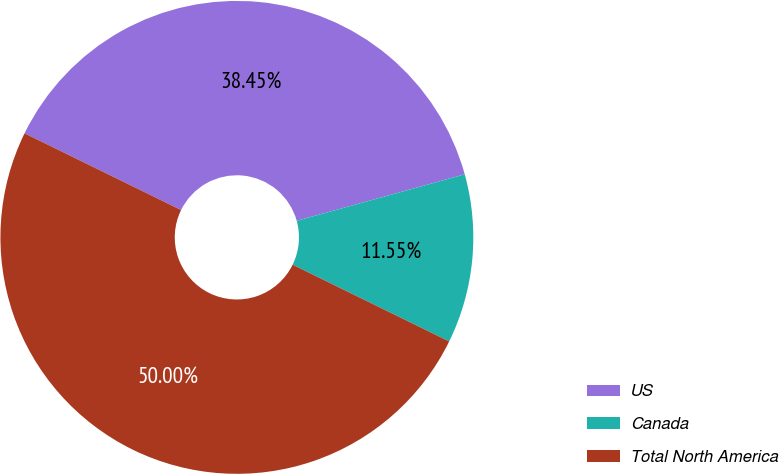Convert chart to OTSL. <chart><loc_0><loc_0><loc_500><loc_500><pie_chart><fcel>US<fcel>Canada<fcel>Total North America<nl><fcel>38.45%<fcel>11.55%<fcel>50.0%<nl></chart> 